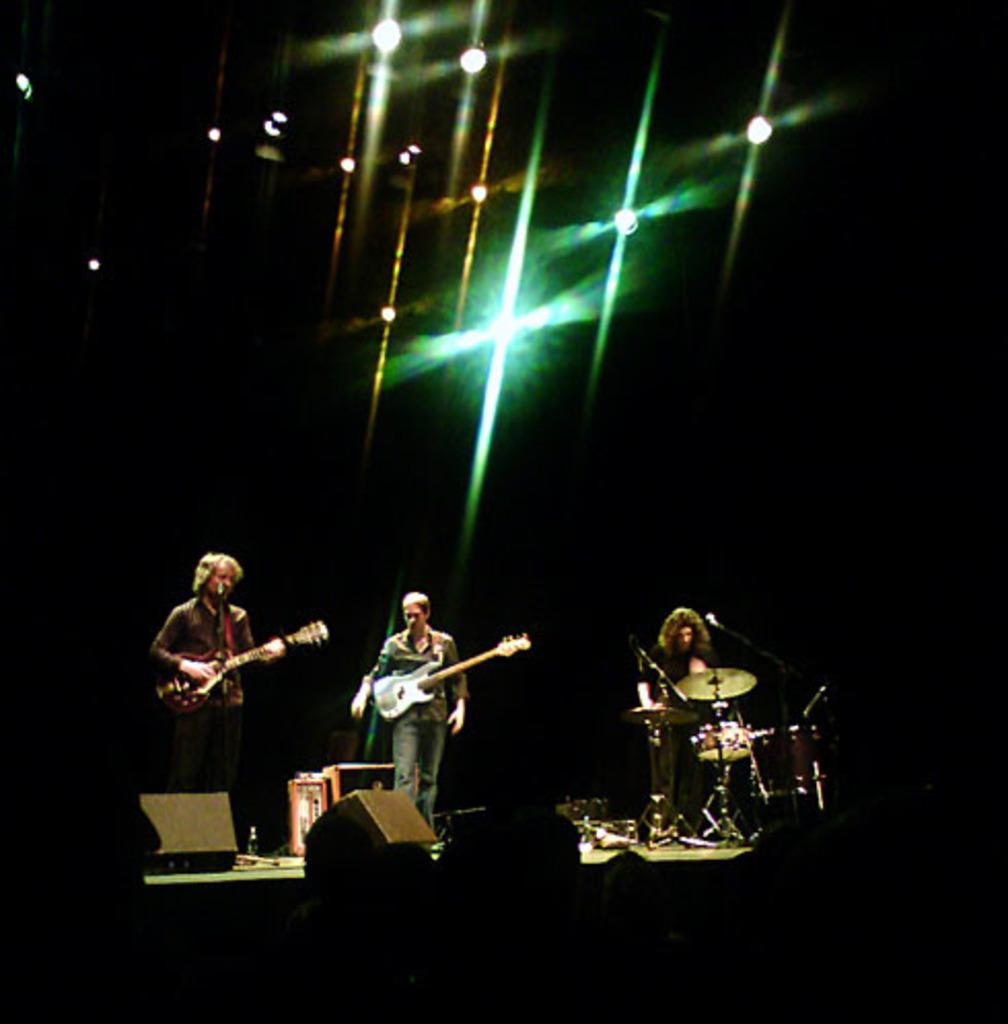How many people are in the image? There are three people in the image. Where are the people located in the image? The three people are on a stage. What are the people doing on the stage? The people are performing. What activity are the people engaged in while performing? The people are playing musical instruments. What type of religious ceremony is being performed by the people on the stage? There is no indication in the image that the performance is related to any religious ceremony. What type of vessel is being used by the people on the stage? There is no vessel present in the image; the people are playing musical instruments. 